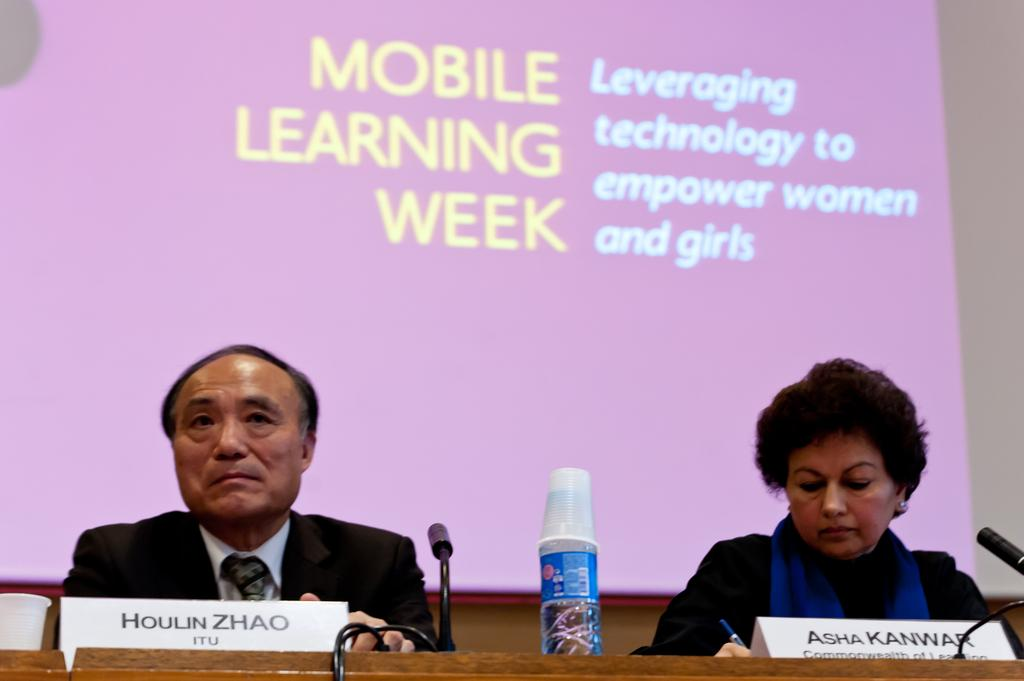<image>
Provide a brief description of the given image. Houlin Zhao of ITU and Asha Kanwar of one of the commonwealths attended Mobile Learning Week where the emphasis was leveraging technology to empower women and girls. 